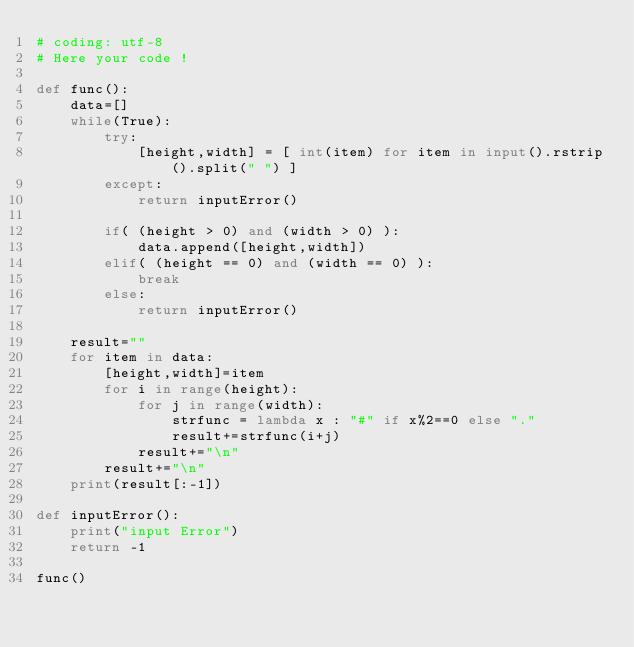Convert code to text. <code><loc_0><loc_0><loc_500><loc_500><_Python_># coding: utf-8
# Here your code !
 
def func():
    data=[]
    while(True):
        try:
            [height,width] = [ int(item) for item in input().rstrip().split(" ") ]
        except:
            return inputError()
         
        if( (height > 0) and (width > 0) ):
            data.append([height,width])
        elif( (height == 0) and (width == 0) ):
            break
        else:
            return inputError()
    
    result=""
    for item in data:
        [height,width]=item
        for i in range(height):
            for j in range(width):
                strfunc = lambda x : "#" if x%2==0 else "."
                result+=strfunc(i+j)
            result+="\n"
        result+="\n"
    print(result[:-1])
        
def inputError():
    print("input Error")
    return -1
 
func()</code> 